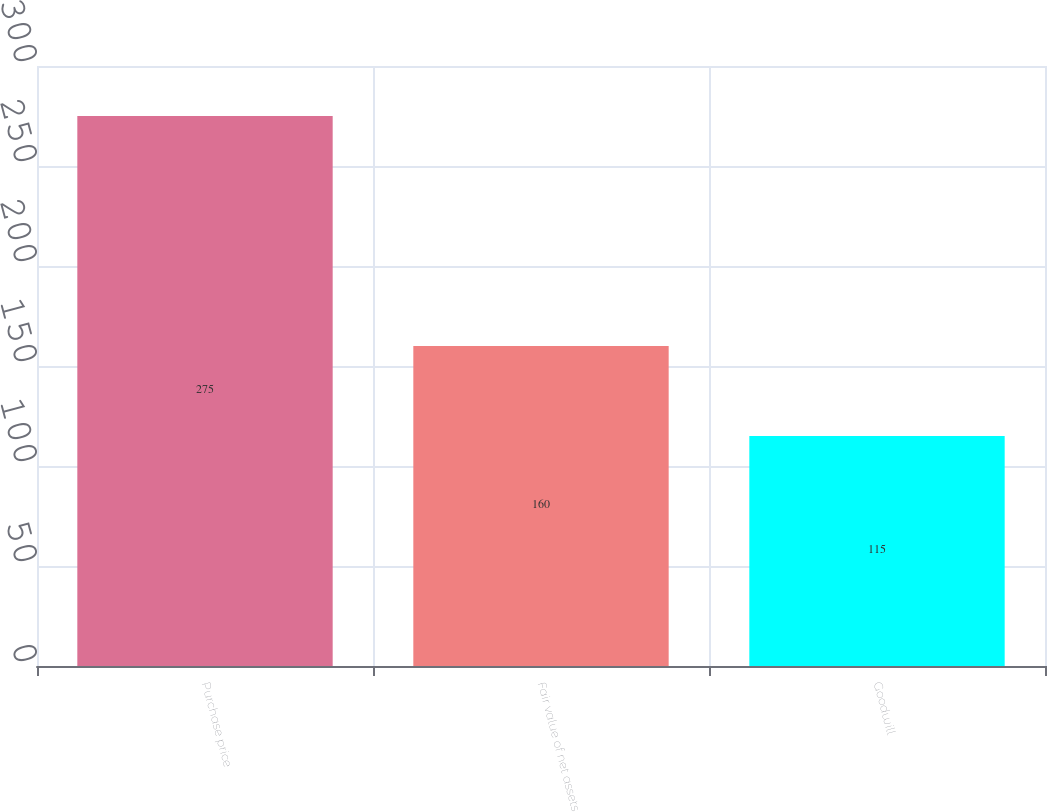<chart> <loc_0><loc_0><loc_500><loc_500><bar_chart><fcel>Purchase price<fcel>Fair value of net assets<fcel>Goodwill<nl><fcel>275<fcel>160<fcel>115<nl></chart> 